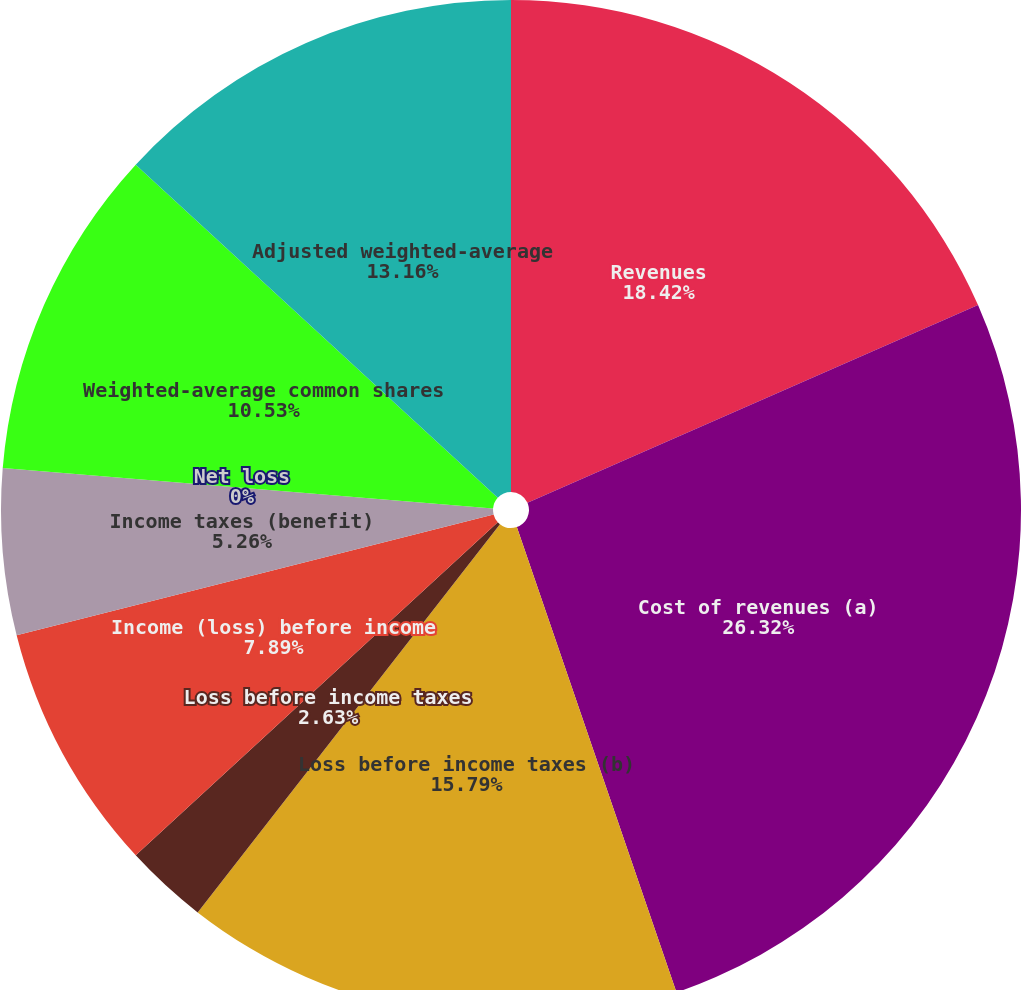Convert chart. <chart><loc_0><loc_0><loc_500><loc_500><pie_chart><fcel>Revenues<fcel>Cost of revenues (a)<fcel>Loss before income taxes (b)<fcel>Loss before income taxes<fcel>Income (loss) before income<fcel>Income taxes (benefit)<fcel>Net loss<fcel>Weighted-average common shares<fcel>Adjusted weighted-average<nl><fcel>18.42%<fcel>26.32%<fcel>15.79%<fcel>2.63%<fcel>7.89%<fcel>5.26%<fcel>0.0%<fcel>10.53%<fcel>13.16%<nl></chart> 